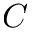Convert formula to latex. <formula><loc_0><loc_0><loc_500><loc_500>C</formula> 